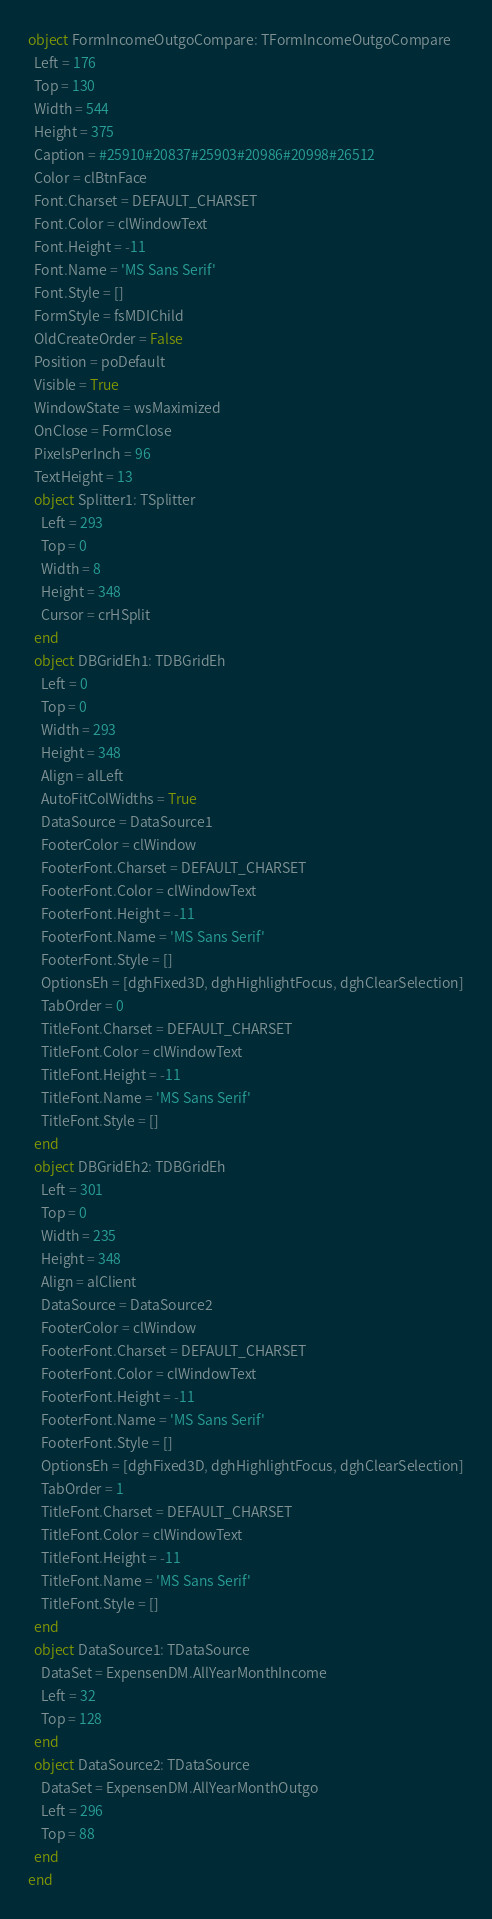Convert code to text. <code><loc_0><loc_0><loc_500><loc_500><_Pascal_>object FormIncomeOutgoCompare: TFormIncomeOutgoCompare
  Left = 176
  Top = 130
  Width = 544
  Height = 375
  Caption = #25910#20837#25903#20986#20998#26512
  Color = clBtnFace
  Font.Charset = DEFAULT_CHARSET
  Font.Color = clWindowText
  Font.Height = -11
  Font.Name = 'MS Sans Serif'
  Font.Style = []
  FormStyle = fsMDIChild
  OldCreateOrder = False
  Position = poDefault
  Visible = True
  WindowState = wsMaximized
  OnClose = FormClose
  PixelsPerInch = 96
  TextHeight = 13
  object Splitter1: TSplitter
    Left = 293
    Top = 0
    Width = 8
    Height = 348
    Cursor = crHSplit
  end
  object DBGridEh1: TDBGridEh
    Left = 0
    Top = 0
    Width = 293
    Height = 348
    Align = alLeft
    AutoFitColWidths = True
    DataSource = DataSource1
    FooterColor = clWindow
    FooterFont.Charset = DEFAULT_CHARSET
    FooterFont.Color = clWindowText
    FooterFont.Height = -11
    FooterFont.Name = 'MS Sans Serif'
    FooterFont.Style = []
    OptionsEh = [dghFixed3D, dghHighlightFocus, dghClearSelection]
    TabOrder = 0
    TitleFont.Charset = DEFAULT_CHARSET
    TitleFont.Color = clWindowText
    TitleFont.Height = -11
    TitleFont.Name = 'MS Sans Serif'
    TitleFont.Style = []
  end
  object DBGridEh2: TDBGridEh
    Left = 301
    Top = 0
    Width = 235
    Height = 348
    Align = alClient
    DataSource = DataSource2
    FooterColor = clWindow
    FooterFont.Charset = DEFAULT_CHARSET
    FooterFont.Color = clWindowText
    FooterFont.Height = -11
    FooterFont.Name = 'MS Sans Serif'
    FooterFont.Style = []
    OptionsEh = [dghFixed3D, dghHighlightFocus, dghClearSelection]
    TabOrder = 1
    TitleFont.Charset = DEFAULT_CHARSET
    TitleFont.Color = clWindowText
    TitleFont.Height = -11
    TitleFont.Name = 'MS Sans Serif'
    TitleFont.Style = []
  end
  object DataSource1: TDataSource
    DataSet = ExpensenDM.AllYearMonthIncome
    Left = 32
    Top = 128
  end
  object DataSource2: TDataSource
    DataSet = ExpensenDM.AllYearMonthOutgo
    Left = 296
    Top = 88
  end
end
</code> 